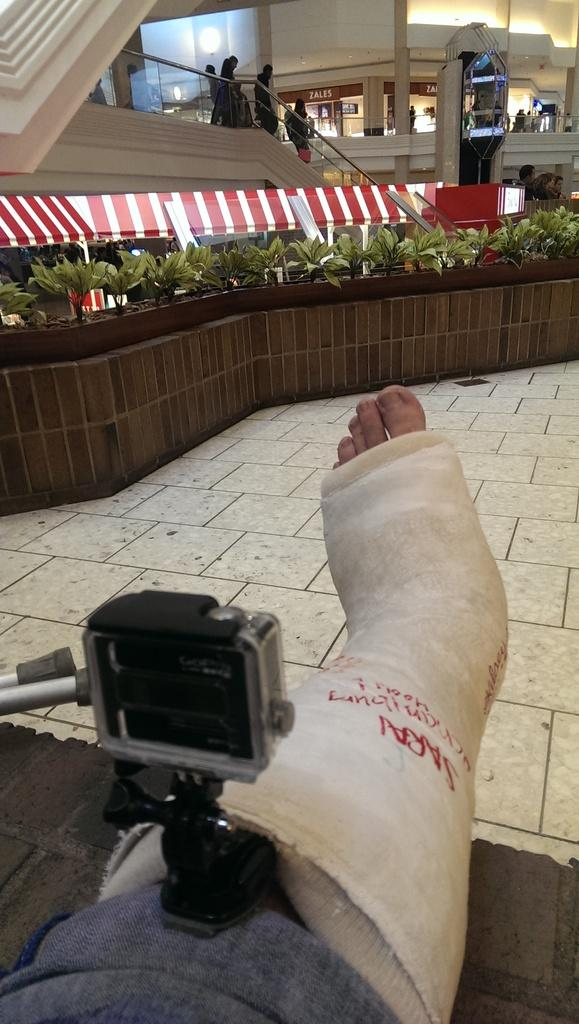What object is placed on a leg in the image? There is a camera on a leg in the image. What can be seen in the background of the image? There are plants, lights, an elevator, and people in the background of the image. What direction is the robin flying in the image? There is no robin present in the image. What scientific theory is being demonstrated in the image? The image does not depict a scientific theory; it shows a camera on a leg and various elements in the background. 